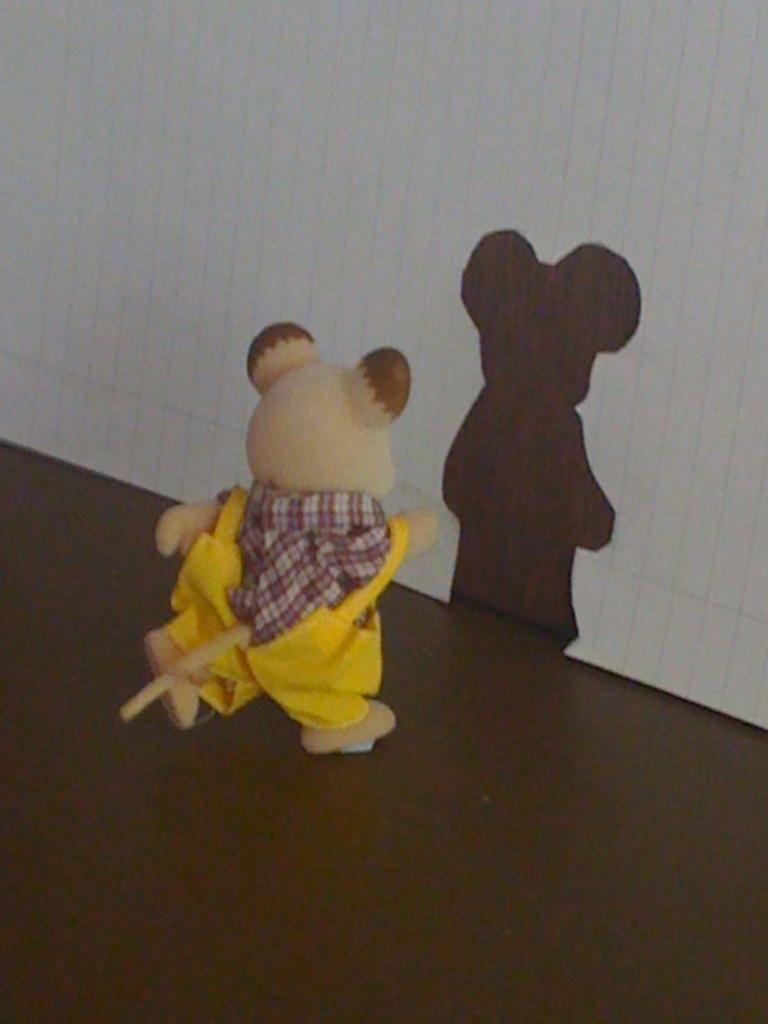What type of toys are in the image? There are small yellow color teddy bear toys in the image. Where are the toys located? The toys are placed on a table. What can be seen on the wall in the background of the image? There is a shadow visible on a white wall in the background of the image. What type of party is being held in the image? There is no indication of a party in the image; it only features small yellow color teddy bear toys on a table and a shadow on a white wall. 